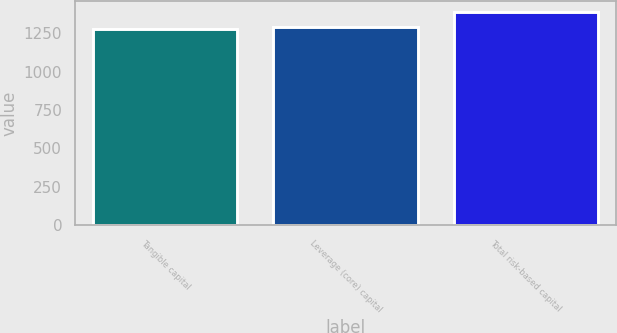Convert chart to OTSL. <chart><loc_0><loc_0><loc_500><loc_500><bar_chart><fcel>Tangible capital<fcel>Leverage (core) capital<fcel>Total risk-based capital<nl><fcel>1278.41<fcel>1289.54<fcel>1389.72<nl></chart> 